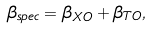<formula> <loc_0><loc_0><loc_500><loc_500>\beta _ { s p e c } = \beta _ { X O } + \beta _ { T O } ,</formula> 